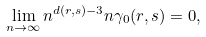Convert formula to latex. <formula><loc_0><loc_0><loc_500><loc_500>\lim _ { n \to \infty } n ^ { d ( r , s ) - 3 } n \gamma _ { 0 } ( r , s ) = 0 ,</formula> 